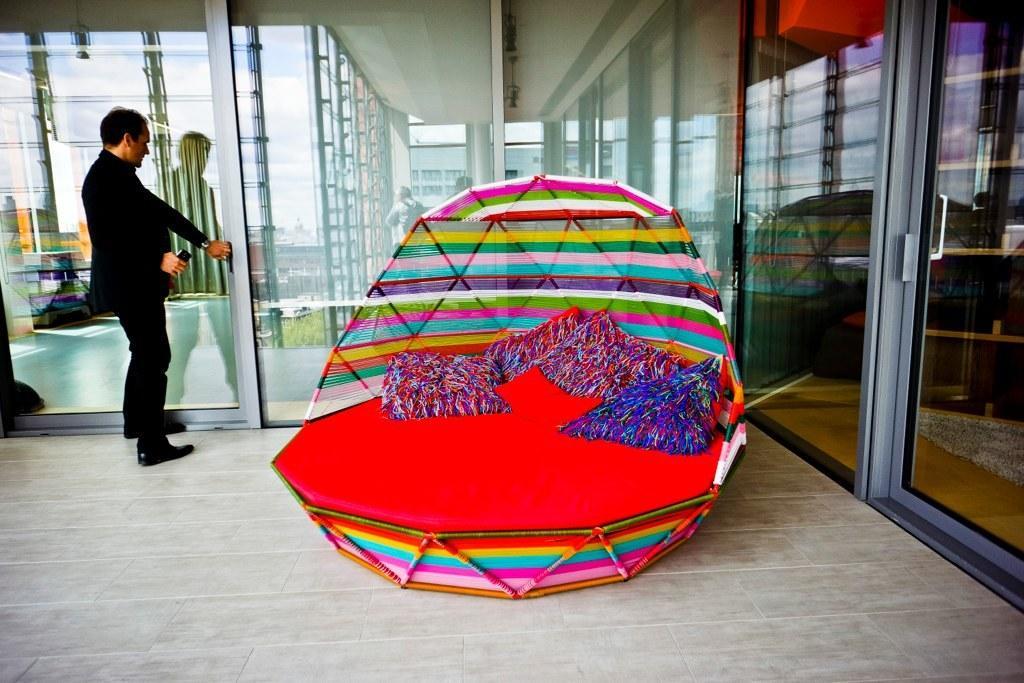How would you summarize this image in a sentence or two? In this image there is a bed. On top of it there are pillows. There is a person opening the door and he is holding the mobile. Around the bed there are glass walls and doors. Through the glass doors we can see a person and there are a few objects on the table. At the bottom of the image there is a floor. 